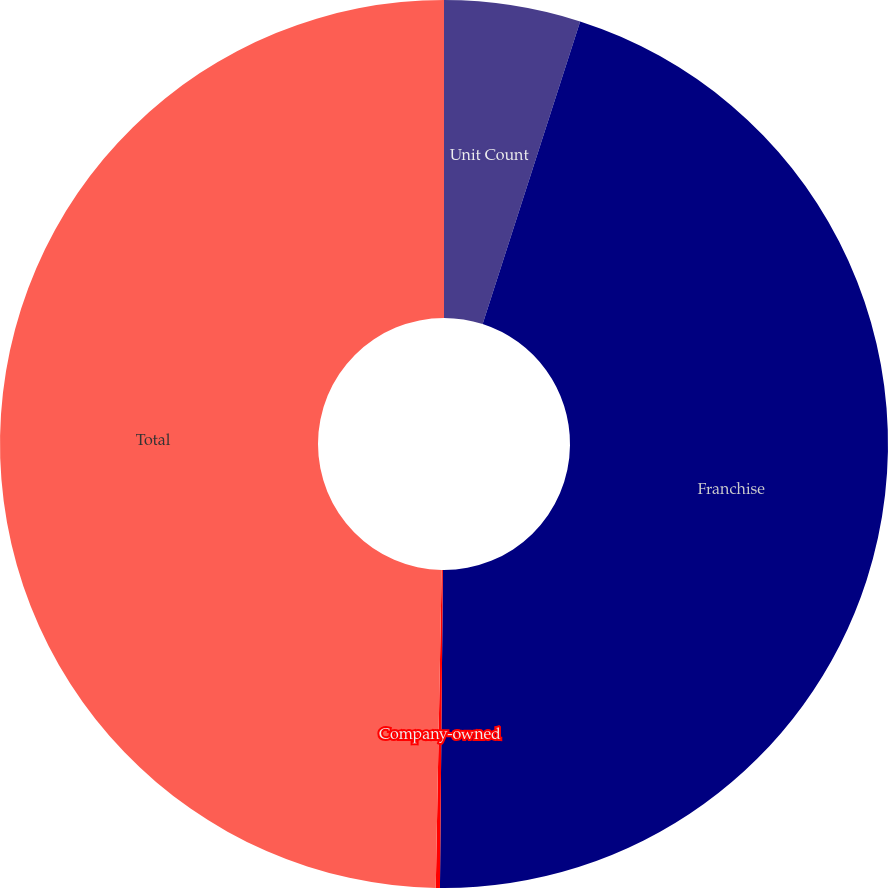Convert chart. <chart><loc_0><loc_0><loc_500><loc_500><pie_chart><fcel>Unit Count<fcel>Franchise<fcel>Company-owned<fcel>Total<nl><fcel>4.96%<fcel>45.18%<fcel>0.15%<fcel>49.7%<nl></chart> 